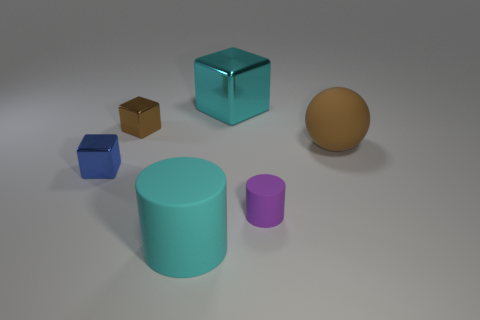Add 3 big purple matte blocks. How many objects exist? 9 Subtract all spheres. How many objects are left? 5 Subtract all brown matte balls. Subtract all large cylinders. How many objects are left? 4 Add 2 tiny purple objects. How many tiny purple objects are left? 3 Add 3 matte cylinders. How many matte cylinders exist? 5 Subtract 0 blue balls. How many objects are left? 6 